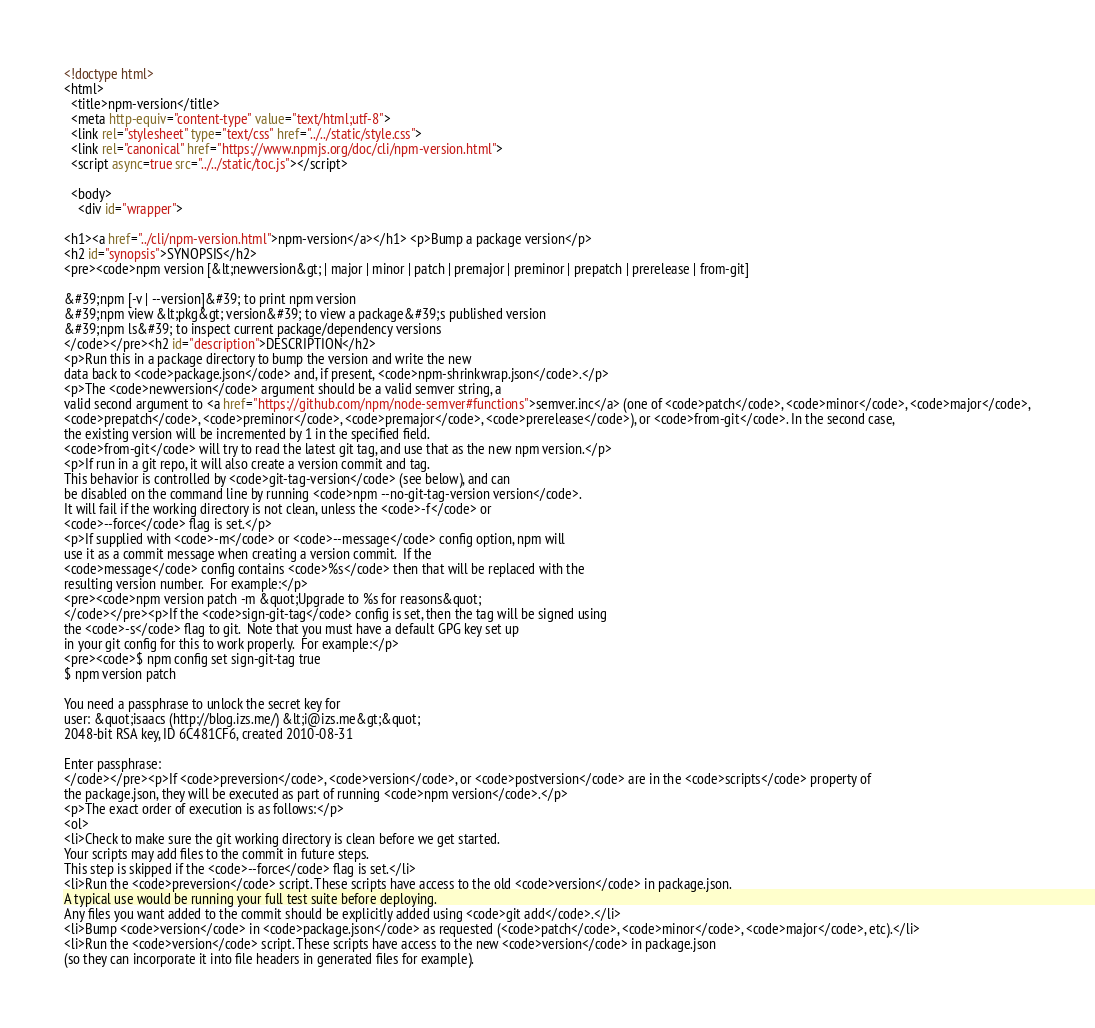<code> <loc_0><loc_0><loc_500><loc_500><_HTML_><!doctype html>
<html>
  <title>npm-version</title>
  <meta http-equiv="content-type" value="text/html;utf-8">
  <link rel="stylesheet" type="text/css" href="../../static/style.css">
  <link rel="canonical" href="https://www.npmjs.org/doc/cli/npm-version.html">
  <script async=true src="../../static/toc.js"></script>

  <body>
    <div id="wrapper">

<h1><a href="../cli/npm-version.html">npm-version</a></h1> <p>Bump a package version</p>
<h2 id="synopsis">SYNOPSIS</h2>
<pre><code>npm version [&lt;newversion&gt; | major | minor | patch | premajor | preminor | prepatch | prerelease | from-git]

&#39;npm [-v | --version]&#39; to print npm version
&#39;npm view &lt;pkg&gt; version&#39; to view a package&#39;s published version
&#39;npm ls&#39; to inspect current package/dependency versions
</code></pre><h2 id="description">DESCRIPTION</h2>
<p>Run this in a package directory to bump the version and write the new
data back to <code>package.json</code> and, if present, <code>npm-shrinkwrap.json</code>.</p>
<p>The <code>newversion</code> argument should be a valid semver string, a
valid second argument to <a href="https://github.com/npm/node-semver#functions">semver.inc</a> (one of <code>patch</code>, <code>minor</code>, <code>major</code>,
<code>prepatch</code>, <code>preminor</code>, <code>premajor</code>, <code>prerelease</code>), or <code>from-git</code>. In the second case,
the existing version will be incremented by 1 in the specified field.
<code>from-git</code> will try to read the latest git tag, and use that as the new npm version.</p>
<p>If run in a git repo, it will also create a version commit and tag.
This behavior is controlled by <code>git-tag-version</code> (see below), and can
be disabled on the command line by running <code>npm --no-git-tag-version version</code>.
It will fail if the working directory is not clean, unless the <code>-f</code> or
<code>--force</code> flag is set.</p>
<p>If supplied with <code>-m</code> or <code>--message</code> config option, npm will
use it as a commit message when creating a version commit.  If the
<code>message</code> config contains <code>%s</code> then that will be replaced with the
resulting version number.  For example:</p>
<pre><code>npm version patch -m &quot;Upgrade to %s for reasons&quot;
</code></pre><p>If the <code>sign-git-tag</code> config is set, then the tag will be signed using
the <code>-s</code> flag to git.  Note that you must have a default GPG key set up
in your git config for this to work properly.  For example:</p>
<pre><code>$ npm config set sign-git-tag true
$ npm version patch

You need a passphrase to unlock the secret key for
user: &quot;isaacs (http://blog.izs.me/) &lt;i@izs.me&gt;&quot;
2048-bit RSA key, ID 6C481CF6, created 2010-08-31

Enter passphrase:
</code></pre><p>If <code>preversion</code>, <code>version</code>, or <code>postversion</code> are in the <code>scripts</code> property of
the package.json, they will be executed as part of running <code>npm version</code>.</p>
<p>The exact order of execution is as follows:</p>
<ol>
<li>Check to make sure the git working directory is clean before we get started.
Your scripts may add files to the commit in future steps.
This step is skipped if the <code>--force</code> flag is set.</li>
<li>Run the <code>preversion</code> script. These scripts have access to the old <code>version</code> in package.json.
A typical use would be running your full test suite before deploying.
Any files you want added to the commit should be explicitly added using <code>git add</code>.</li>
<li>Bump <code>version</code> in <code>package.json</code> as requested (<code>patch</code>, <code>minor</code>, <code>major</code>, etc).</li>
<li>Run the <code>version</code> script. These scripts have access to the new <code>version</code> in package.json
(so they can incorporate it into file headers in generated files for example).</code> 